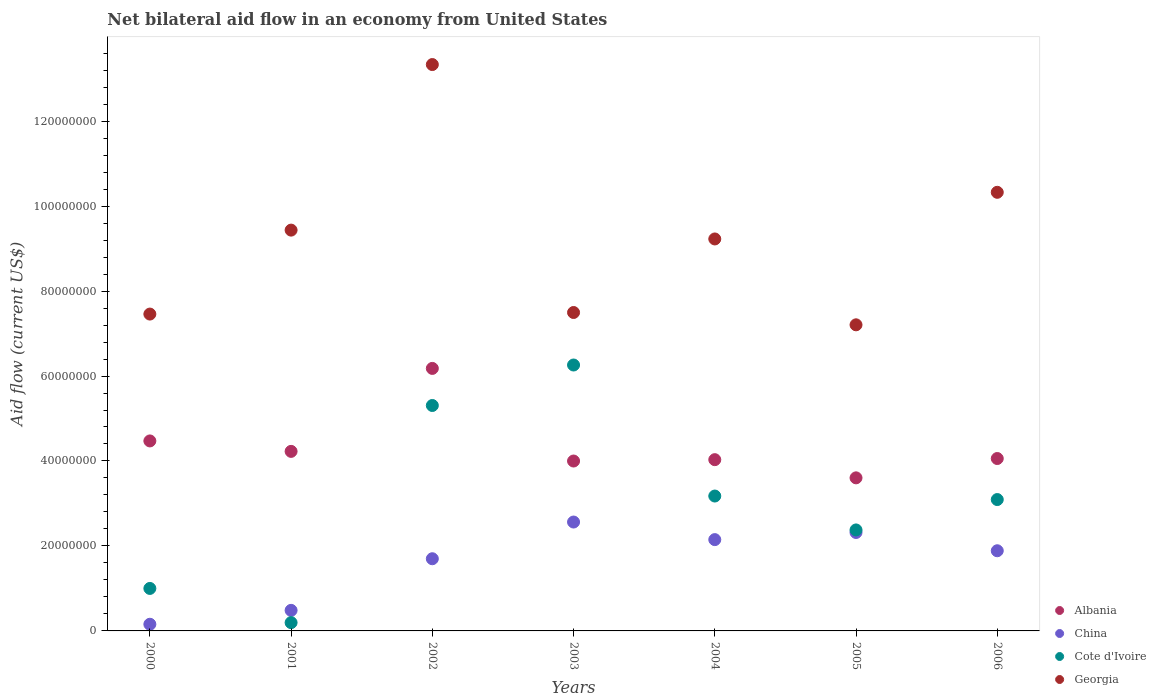How many different coloured dotlines are there?
Your answer should be very brief. 4. What is the net bilateral aid flow in China in 2002?
Provide a succinct answer. 1.70e+07. Across all years, what is the maximum net bilateral aid flow in China?
Your answer should be compact. 2.56e+07. Across all years, what is the minimum net bilateral aid flow in Cote d'Ivoire?
Offer a terse response. 1.95e+06. What is the total net bilateral aid flow in China in the graph?
Your answer should be compact. 1.13e+08. What is the difference between the net bilateral aid flow in Albania in 2002 and that in 2006?
Ensure brevity in your answer.  2.12e+07. What is the difference between the net bilateral aid flow in China in 2002 and the net bilateral aid flow in Georgia in 2000?
Your answer should be very brief. -5.76e+07. What is the average net bilateral aid flow in Albania per year?
Make the answer very short. 4.37e+07. In the year 2001, what is the difference between the net bilateral aid flow in Albania and net bilateral aid flow in Georgia?
Your response must be concise. -5.21e+07. What is the ratio of the net bilateral aid flow in China in 2004 to that in 2006?
Provide a succinct answer. 1.14. What is the difference between the highest and the second highest net bilateral aid flow in Cote d'Ivoire?
Provide a short and direct response. 9.53e+06. What is the difference between the highest and the lowest net bilateral aid flow in Cote d'Ivoire?
Your response must be concise. 6.06e+07. In how many years, is the net bilateral aid flow in China greater than the average net bilateral aid flow in China taken over all years?
Give a very brief answer. 5. Is it the case that in every year, the sum of the net bilateral aid flow in China and net bilateral aid flow in Georgia  is greater than the net bilateral aid flow in Albania?
Make the answer very short. Yes. Does the net bilateral aid flow in Albania monotonically increase over the years?
Offer a terse response. No. Is the net bilateral aid flow in Albania strictly greater than the net bilateral aid flow in Georgia over the years?
Provide a succinct answer. No. Is the net bilateral aid flow in Cote d'Ivoire strictly less than the net bilateral aid flow in Albania over the years?
Make the answer very short. No. Are the values on the major ticks of Y-axis written in scientific E-notation?
Your answer should be very brief. No. Does the graph contain any zero values?
Offer a very short reply. No. Does the graph contain grids?
Your answer should be very brief. No. How are the legend labels stacked?
Keep it short and to the point. Vertical. What is the title of the graph?
Your answer should be very brief. Net bilateral aid flow in an economy from United States. What is the label or title of the Y-axis?
Give a very brief answer. Aid flow (current US$). What is the Aid flow (current US$) of Albania in 2000?
Offer a terse response. 4.47e+07. What is the Aid flow (current US$) in China in 2000?
Your answer should be very brief. 1.57e+06. What is the Aid flow (current US$) in Georgia in 2000?
Ensure brevity in your answer.  7.46e+07. What is the Aid flow (current US$) in Albania in 2001?
Offer a very short reply. 4.23e+07. What is the Aid flow (current US$) in China in 2001?
Make the answer very short. 4.84e+06. What is the Aid flow (current US$) of Cote d'Ivoire in 2001?
Offer a very short reply. 1.95e+06. What is the Aid flow (current US$) in Georgia in 2001?
Ensure brevity in your answer.  9.43e+07. What is the Aid flow (current US$) in Albania in 2002?
Make the answer very short. 6.18e+07. What is the Aid flow (current US$) in China in 2002?
Keep it short and to the point. 1.70e+07. What is the Aid flow (current US$) of Cote d'Ivoire in 2002?
Offer a terse response. 5.31e+07. What is the Aid flow (current US$) of Georgia in 2002?
Make the answer very short. 1.33e+08. What is the Aid flow (current US$) of Albania in 2003?
Keep it short and to the point. 4.00e+07. What is the Aid flow (current US$) in China in 2003?
Give a very brief answer. 2.56e+07. What is the Aid flow (current US$) in Cote d'Ivoire in 2003?
Offer a terse response. 6.26e+07. What is the Aid flow (current US$) in Georgia in 2003?
Your answer should be compact. 7.50e+07. What is the Aid flow (current US$) in Albania in 2004?
Make the answer very short. 4.03e+07. What is the Aid flow (current US$) in China in 2004?
Provide a short and direct response. 2.15e+07. What is the Aid flow (current US$) of Cote d'Ivoire in 2004?
Your response must be concise. 3.18e+07. What is the Aid flow (current US$) of Georgia in 2004?
Keep it short and to the point. 9.23e+07. What is the Aid flow (current US$) in Albania in 2005?
Keep it short and to the point. 3.60e+07. What is the Aid flow (current US$) in China in 2005?
Give a very brief answer. 2.32e+07. What is the Aid flow (current US$) of Cote d'Ivoire in 2005?
Offer a terse response. 2.38e+07. What is the Aid flow (current US$) of Georgia in 2005?
Your answer should be compact. 7.20e+07. What is the Aid flow (current US$) of Albania in 2006?
Keep it short and to the point. 4.06e+07. What is the Aid flow (current US$) in China in 2006?
Give a very brief answer. 1.89e+07. What is the Aid flow (current US$) in Cote d'Ivoire in 2006?
Provide a succinct answer. 3.09e+07. What is the Aid flow (current US$) of Georgia in 2006?
Your response must be concise. 1.03e+08. Across all years, what is the maximum Aid flow (current US$) of Albania?
Provide a succinct answer. 6.18e+07. Across all years, what is the maximum Aid flow (current US$) in China?
Give a very brief answer. 2.56e+07. Across all years, what is the maximum Aid flow (current US$) in Cote d'Ivoire?
Your answer should be compact. 6.26e+07. Across all years, what is the maximum Aid flow (current US$) in Georgia?
Make the answer very short. 1.33e+08. Across all years, what is the minimum Aid flow (current US$) in Albania?
Keep it short and to the point. 3.60e+07. Across all years, what is the minimum Aid flow (current US$) of China?
Keep it short and to the point. 1.57e+06. Across all years, what is the minimum Aid flow (current US$) of Cote d'Ivoire?
Ensure brevity in your answer.  1.95e+06. Across all years, what is the minimum Aid flow (current US$) in Georgia?
Offer a very short reply. 7.20e+07. What is the total Aid flow (current US$) of Albania in the graph?
Give a very brief answer. 3.06e+08. What is the total Aid flow (current US$) of China in the graph?
Keep it short and to the point. 1.13e+08. What is the total Aid flow (current US$) in Cote d'Ivoire in the graph?
Make the answer very short. 2.14e+08. What is the total Aid flow (current US$) in Georgia in the graph?
Make the answer very short. 6.45e+08. What is the difference between the Aid flow (current US$) of Albania in 2000 and that in 2001?
Keep it short and to the point. 2.46e+06. What is the difference between the Aid flow (current US$) in China in 2000 and that in 2001?
Give a very brief answer. -3.27e+06. What is the difference between the Aid flow (current US$) in Cote d'Ivoire in 2000 and that in 2001?
Ensure brevity in your answer.  8.05e+06. What is the difference between the Aid flow (current US$) of Georgia in 2000 and that in 2001?
Provide a succinct answer. -1.98e+07. What is the difference between the Aid flow (current US$) of Albania in 2000 and that in 2002?
Offer a very short reply. -1.71e+07. What is the difference between the Aid flow (current US$) in China in 2000 and that in 2002?
Your answer should be compact. -1.54e+07. What is the difference between the Aid flow (current US$) of Cote d'Ivoire in 2000 and that in 2002?
Offer a terse response. -4.31e+07. What is the difference between the Aid flow (current US$) in Georgia in 2000 and that in 2002?
Offer a very short reply. -5.87e+07. What is the difference between the Aid flow (current US$) of Albania in 2000 and that in 2003?
Your answer should be very brief. 4.73e+06. What is the difference between the Aid flow (current US$) in China in 2000 and that in 2003?
Your answer should be very brief. -2.41e+07. What is the difference between the Aid flow (current US$) in Cote d'Ivoire in 2000 and that in 2003?
Your response must be concise. -5.26e+07. What is the difference between the Aid flow (current US$) in Georgia in 2000 and that in 2003?
Offer a very short reply. -3.70e+05. What is the difference between the Aid flow (current US$) of Albania in 2000 and that in 2004?
Your answer should be compact. 4.41e+06. What is the difference between the Aid flow (current US$) of China in 2000 and that in 2004?
Ensure brevity in your answer.  -1.99e+07. What is the difference between the Aid flow (current US$) in Cote d'Ivoire in 2000 and that in 2004?
Provide a succinct answer. -2.18e+07. What is the difference between the Aid flow (current US$) of Georgia in 2000 and that in 2004?
Ensure brevity in your answer.  -1.77e+07. What is the difference between the Aid flow (current US$) of Albania in 2000 and that in 2005?
Keep it short and to the point. 8.69e+06. What is the difference between the Aid flow (current US$) of China in 2000 and that in 2005?
Give a very brief answer. -2.16e+07. What is the difference between the Aid flow (current US$) in Cote d'Ivoire in 2000 and that in 2005?
Your answer should be compact. -1.38e+07. What is the difference between the Aid flow (current US$) of Georgia in 2000 and that in 2005?
Keep it short and to the point. 2.53e+06. What is the difference between the Aid flow (current US$) of Albania in 2000 and that in 2006?
Your answer should be very brief. 4.14e+06. What is the difference between the Aid flow (current US$) in China in 2000 and that in 2006?
Offer a very short reply. -1.73e+07. What is the difference between the Aid flow (current US$) in Cote d'Ivoire in 2000 and that in 2006?
Your response must be concise. -2.09e+07. What is the difference between the Aid flow (current US$) of Georgia in 2000 and that in 2006?
Provide a succinct answer. -2.87e+07. What is the difference between the Aid flow (current US$) of Albania in 2001 and that in 2002?
Provide a short and direct response. -1.95e+07. What is the difference between the Aid flow (current US$) in China in 2001 and that in 2002?
Offer a very short reply. -1.22e+07. What is the difference between the Aid flow (current US$) of Cote d'Ivoire in 2001 and that in 2002?
Offer a very short reply. -5.11e+07. What is the difference between the Aid flow (current US$) of Georgia in 2001 and that in 2002?
Offer a very short reply. -3.90e+07. What is the difference between the Aid flow (current US$) of Albania in 2001 and that in 2003?
Your answer should be compact. 2.27e+06. What is the difference between the Aid flow (current US$) in China in 2001 and that in 2003?
Offer a terse response. -2.08e+07. What is the difference between the Aid flow (current US$) in Cote d'Ivoire in 2001 and that in 2003?
Offer a terse response. -6.06e+07. What is the difference between the Aid flow (current US$) of Georgia in 2001 and that in 2003?
Your answer should be compact. 1.94e+07. What is the difference between the Aid flow (current US$) in Albania in 2001 and that in 2004?
Ensure brevity in your answer.  1.95e+06. What is the difference between the Aid flow (current US$) in China in 2001 and that in 2004?
Provide a succinct answer. -1.66e+07. What is the difference between the Aid flow (current US$) in Cote d'Ivoire in 2001 and that in 2004?
Give a very brief answer. -2.98e+07. What is the difference between the Aid flow (current US$) of Georgia in 2001 and that in 2004?
Keep it short and to the point. 2.08e+06. What is the difference between the Aid flow (current US$) in Albania in 2001 and that in 2005?
Your answer should be very brief. 6.23e+06. What is the difference between the Aid flow (current US$) in China in 2001 and that in 2005?
Make the answer very short. -1.83e+07. What is the difference between the Aid flow (current US$) of Cote d'Ivoire in 2001 and that in 2005?
Make the answer very short. -2.18e+07. What is the difference between the Aid flow (current US$) of Georgia in 2001 and that in 2005?
Ensure brevity in your answer.  2.23e+07. What is the difference between the Aid flow (current US$) of Albania in 2001 and that in 2006?
Offer a terse response. 1.68e+06. What is the difference between the Aid flow (current US$) in China in 2001 and that in 2006?
Your answer should be very brief. -1.40e+07. What is the difference between the Aid flow (current US$) in Cote d'Ivoire in 2001 and that in 2006?
Offer a terse response. -2.90e+07. What is the difference between the Aid flow (current US$) in Georgia in 2001 and that in 2006?
Your response must be concise. -8.90e+06. What is the difference between the Aid flow (current US$) of Albania in 2002 and that in 2003?
Provide a succinct answer. 2.18e+07. What is the difference between the Aid flow (current US$) of China in 2002 and that in 2003?
Offer a very short reply. -8.64e+06. What is the difference between the Aid flow (current US$) of Cote d'Ivoire in 2002 and that in 2003?
Keep it short and to the point. -9.53e+06. What is the difference between the Aid flow (current US$) in Georgia in 2002 and that in 2003?
Offer a terse response. 5.84e+07. What is the difference between the Aid flow (current US$) of Albania in 2002 and that in 2004?
Your answer should be very brief. 2.15e+07. What is the difference between the Aid flow (current US$) in China in 2002 and that in 2004?
Make the answer very short. -4.50e+06. What is the difference between the Aid flow (current US$) of Cote d'Ivoire in 2002 and that in 2004?
Make the answer very short. 2.13e+07. What is the difference between the Aid flow (current US$) in Georgia in 2002 and that in 2004?
Ensure brevity in your answer.  4.10e+07. What is the difference between the Aid flow (current US$) of Albania in 2002 and that in 2005?
Keep it short and to the point. 2.58e+07. What is the difference between the Aid flow (current US$) in China in 2002 and that in 2005?
Keep it short and to the point. -6.18e+06. What is the difference between the Aid flow (current US$) of Cote d'Ivoire in 2002 and that in 2005?
Your answer should be very brief. 2.93e+07. What is the difference between the Aid flow (current US$) in Georgia in 2002 and that in 2005?
Provide a succinct answer. 6.13e+07. What is the difference between the Aid flow (current US$) in Albania in 2002 and that in 2006?
Make the answer very short. 2.12e+07. What is the difference between the Aid flow (current US$) in China in 2002 and that in 2006?
Provide a short and direct response. -1.88e+06. What is the difference between the Aid flow (current US$) of Cote d'Ivoire in 2002 and that in 2006?
Ensure brevity in your answer.  2.21e+07. What is the difference between the Aid flow (current US$) in Georgia in 2002 and that in 2006?
Provide a short and direct response. 3.01e+07. What is the difference between the Aid flow (current US$) in Albania in 2003 and that in 2004?
Ensure brevity in your answer.  -3.20e+05. What is the difference between the Aid flow (current US$) in China in 2003 and that in 2004?
Keep it short and to the point. 4.14e+06. What is the difference between the Aid flow (current US$) in Cote d'Ivoire in 2003 and that in 2004?
Offer a very short reply. 3.08e+07. What is the difference between the Aid flow (current US$) in Georgia in 2003 and that in 2004?
Your answer should be very brief. -1.73e+07. What is the difference between the Aid flow (current US$) of Albania in 2003 and that in 2005?
Provide a succinct answer. 3.96e+06. What is the difference between the Aid flow (current US$) of China in 2003 and that in 2005?
Offer a very short reply. 2.46e+06. What is the difference between the Aid flow (current US$) in Cote d'Ivoire in 2003 and that in 2005?
Your answer should be compact. 3.88e+07. What is the difference between the Aid flow (current US$) of Georgia in 2003 and that in 2005?
Provide a short and direct response. 2.90e+06. What is the difference between the Aid flow (current US$) of Albania in 2003 and that in 2006?
Your answer should be compact. -5.90e+05. What is the difference between the Aid flow (current US$) in China in 2003 and that in 2006?
Give a very brief answer. 6.76e+06. What is the difference between the Aid flow (current US$) of Cote d'Ivoire in 2003 and that in 2006?
Offer a terse response. 3.17e+07. What is the difference between the Aid flow (current US$) in Georgia in 2003 and that in 2006?
Your response must be concise. -2.83e+07. What is the difference between the Aid flow (current US$) of Albania in 2004 and that in 2005?
Keep it short and to the point. 4.28e+06. What is the difference between the Aid flow (current US$) in China in 2004 and that in 2005?
Ensure brevity in your answer.  -1.68e+06. What is the difference between the Aid flow (current US$) in Cote d'Ivoire in 2004 and that in 2005?
Keep it short and to the point. 7.98e+06. What is the difference between the Aid flow (current US$) in Georgia in 2004 and that in 2005?
Your answer should be compact. 2.02e+07. What is the difference between the Aid flow (current US$) in China in 2004 and that in 2006?
Your answer should be very brief. 2.62e+06. What is the difference between the Aid flow (current US$) in Cote d'Ivoire in 2004 and that in 2006?
Offer a very short reply. 8.30e+05. What is the difference between the Aid flow (current US$) of Georgia in 2004 and that in 2006?
Your answer should be compact. -1.10e+07. What is the difference between the Aid flow (current US$) of Albania in 2005 and that in 2006?
Your answer should be very brief. -4.55e+06. What is the difference between the Aid flow (current US$) of China in 2005 and that in 2006?
Ensure brevity in your answer.  4.30e+06. What is the difference between the Aid flow (current US$) of Cote d'Ivoire in 2005 and that in 2006?
Your answer should be very brief. -7.15e+06. What is the difference between the Aid flow (current US$) in Georgia in 2005 and that in 2006?
Your response must be concise. -3.12e+07. What is the difference between the Aid flow (current US$) in Albania in 2000 and the Aid flow (current US$) in China in 2001?
Give a very brief answer. 3.99e+07. What is the difference between the Aid flow (current US$) in Albania in 2000 and the Aid flow (current US$) in Cote d'Ivoire in 2001?
Provide a short and direct response. 4.28e+07. What is the difference between the Aid flow (current US$) in Albania in 2000 and the Aid flow (current US$) in Georgia in 2001?
Offer a very short reply. -4.96e+07. What is the difference between the Aid flow (current US$) in China in 2000 and the Aid flow (current US$) in Cote d'Ivoire in 2001?
Provide a succinct answer. -3.80e+05. What is the difference between the Aid flow (current US$) of China in 2000 and the Aid flow (current US$) of Georgia in 2001?
Your response must be concise. -9.28e+07. What is the difference between the Aid flow (current US$) of Cote d'Ivoire in 2000 and the Aid flow (current US$) of Georgia in 2001?
Your answer should be very brief. -8.43e+07. What is the difference between the Aid flow (current US$) of Albania in 2000 and the Aid flow (current US$) of China in 2002?
Offer a terse response. 2.77e+07. What is the difference between the Aid flow (current US$) in Albania in 2000 and the Aid flow (current US$) in Cote d'Ivoire in 2002?
Offer a terse response. -8.34e+06. What is the difference between the Aid flow (current US$) in Albania in 2000 and the Aid flow (current US$) in Georgia in 2002?
Your answer should be compact. -8.86e+07. What is the difference between the Aid flow (current US$) of China in 2000 and the Aid flow (current US$) of Cote d'Ivoire in 2002?
Ensure brevity in your answer.  -5.15e+07. What is the difference between the Aid flow (current US$) of China in 2000 and the Aid flow (current US$) of Georgia in 2002?
Your answer should be very brief. -1.32e+08. What is the difference between the Aid flow (current US$) in Cote d'Ivoire in 2000 and the Aid flow (current US$) in Georgia in 2002?
Ensure brevity in your answer.  -1.23e+08. What is the difference between the Aid flow (current US$) in Albania in 2000 and the Aid flow (current US$) in China in 2003?
Offer a terse response. 1.91e+07. What is the difference between the Aid flow (current US$) of Albania in 2000 and the Aid flow (current US$) of Cote d'Ivoire in 2003?
Keep it short and to the point. -1.79e+07. What is the difference between the Aid flow (current US$) in Albania in 2000 and the Aid flow (current US$) in Georgia in 2003?
Ensure brevity in your answer.  -3.02e+07. What is the difference between the Aid flow (current US$) in China in 2000 and the Aid flow (current US$) in Cote d'Ivoire in 2003?
Give a very brief answer. -6.10e+07. What is the difference between the Aid flow (current US$) of China in 2000 and the Aid flow (current US$) of Georgia in 2003?
Your answer should be compact. -7.34e+07. What is the difference between the Aid flow (current US$) of Cote d'Ivoire in 2000 and the Aid flow (current US$) of Georgia in 2003?
Keep it short and to the point. -6.50e+07. What is the difference between the Aid flow (current US$) of Albania in 2000 and the Aid flow (current US$) of China in 2004?
Offer a terse response. 2.32e+07. What is the difference between the Aid flow (current US$) of Albania in 2000 and the Aid flow (current US$) of Cote d'Ivoire in 2004?
Offer a terse response. 1.30e+07. What is the difference between the Aid flow (current US$) of Albania in 2000 and the Aid flow (current US$) of Georgia in 2004?
Keep it short and to the point. -4.75e+07. What is the difference between the Aid flow (current US$) in China in 2000 and the Aid flow (current US$) in Cote d'Ivoire in 2004?
Your response must be concise. -3.02e+07. What is the difference between the Aid flow (current US$) of China in 2000 and the Aid flow (current US$) of Georgia in 2004?
Ensure brevity in your answer.  -9.07e+07. What is the difference between the Aid flow (current US$) of Cote d'Ivoire in 2000 and the Aid flow (current US$) of Georgia in 2004?
Make the answer very short. -8.23e+07. What is the difference between the Aid flow (current US$) in Albania in 2000 and the Aid flow (current US$) in China in 2005?
Make the answer very short. 2.16e+07. What is the difference between the Aid flow (current US$) in Albania in 2000 and the Aid flow (current US$) in Cote d'Ivoire in 2005?
Provide a succinct answer. 2.10e+07. What is the difference between the Aid flow (current US$) of Albania in 2000 and the Aid flow (current US$) of Georgia in 2005?
Provide a short and direct response. -2.73e+07. What is the difference between the Aid flow (current US$) in China in 2000 and the Aid flow (current US$) in Cote d'Ivoire in 2005?
Ensure brevity in your answer.  -2.22e+07. What is the difference between the Aid flow (current US$) in China in 2000 and the Aid flow (current US$) in Georgia in 2005?
Your answer should be very brief. -7.05e+07. What is the difference between the Aid flow (current US$) of Cote d'Ivoire in 2000 and the Aid flow (current US$) of Georgia in 2005?
Keep it short and to the point. -6.20e+07. What is the difference between the Aid flow (current US$) in Albania in 2000 and the Aid flow (current US$) in China in 2006?
Provide a short and direct response. 2.58e+07. What is the difference between the Aid flow (current US$) in Albania in 2000 and the Aid flow (current US$) in Cote d'Ivoire in 2006?
Give a very brief answer. 1.38e+07. What is the difference between the Aid flow (current US$) in Albania in 2000 and the Aid flow (current US$) in Georgia in 2006?
Keep it short and to the point. -5.85e+07. What is the difference between the Aid flow (current US$) in China in 2000 and the Aid flow (current US$) in Cote d'Ivoire in 2006?
Make the answer very short. -2.94e+07. What is the difference between the Aid flow (current US$) in China in 2000 and the Aid flow (current US$) in Georgia in 2006?
Offer a very short reply. -1.02e+08. What is the difference between the Aid flow (current US$) in Cote d'Ivoire in 2000 and the Aid flow (current US$) in Georgia in 2006?
Keep it short and to the point. -9.32e+07. What is the difference between the Aid flow (current US$) of Albania in 2001 and the Aid flow (current US$) of China in 2002?
Give a very brief answer. 2.53e+07. What is the difference between the Aid flow (current US$) of Albania in 2001 and the Aid flow (current US$) of Cote d'Ivoire in 2002?
Provide a short and direct response. -1.08e+07. What is the difference between the Aid flow (current US$) in Albania in 2001 and the Aid flow (current US$) in Georgia in 2002?
Provide a short and direct response. -9.10e+07. What is the difference between the Aid flow (current US$) in China in 2001 and the Aid flow (current US$) in Cote d'Ivoire in 2002?
Offer a terse response. -4.82e+07. What is the difference between the Aid flow (current US$) in China in 2001 and the Aid flow (current US$) in Georgia in 2002?
Offer a terse response. -1.28e+08. What is the difference between the Aid flow (current US$) of Cote d'Ivoire in 2001 and the Aid flow (current US$) of Georgia in 2002?
Provide a succinct answer. -1.31e+08. What is the difference between the Aid flow (current US$) of Albania in 2001 and the Aid flow (current US$) of China in 2003?
Keep it short and to the point. 1.66e+07. What is the difference between the Aid flow (current US$) in Albania in 2001 and the Aid flow (current US$) in Cote d'Ivoire in 2003?
Your answer should be compact. -2.03e+07. What is the difference between the Aid flow (current US$) in Albania in 2001 and the Aid flow (current US$) in Georgia in 2003?
Offer a terse response. -3.27e+07. What is the difference between the Aid flow (current US$) of China in 2001 and the Aid flow (current US$) of Cote d'Ivoire in 2003?
Your answer should be very brief. -5.78e+07. What is the difference between the Aid flow (current US$) in China in 2001 and the Aid flow (current US$) in Georgia in 2003?
Your answer should be very brief. -7.01e+07. What is the difference between the Aid flow (current US$) of Cote d'Ivoire in 2001 and the Aid flow (current US$) of Georgia in 2003?
Provide a succinct answer. -7.30e+07. What is the difference between the Aid flow (current US$) in Albania in 2001 and the Aid flow (current US$) in China in 2004?
Offer a very short reply. 2.08e+07. What is the difference between the Aid flow (current US$) of Albania in 2001 and the Aid flow (current US$) of Cote d'Ivoire in 2004?
Provide a succinct answer. 1.05e+07. What is the difference between the Aid flow (current US$) of Albania in 2001 and the Aid flow (current US$) of Georgia in 2004?
Ensure brevity in your answer.  -5.00e+07. What is the difference between the Aid flow (current US$) in China in 2001 and the Aid flow (current US$) in Cote d'Ivoire in 2004?
Offer a terse response. -2.69e+07. What is the difference between the Aid flow (current US$) in China in 2001 and the Aid flow (current US$) in Georgia in 2004?
Ensure brevity in your answer.  -8.74e+07. What is the difference between the Aid flow (current US$) of Cote d'Ivoire in 2001 and the Aid flow (current US$) of Georgia in 2004?
Give a very brief answer. -9.03e+07. What is the difference between the Aid flow (current US$) of Albania in 2001 and the Aid flow (current US$) of China in 2005?
Your answer should be compact. 1.91e+07. What is the difference between the Aid flow (current US$) in Albania in 2001 and the Aid flow (current US$) in Cote d'Ivoire in 2005?
Offer a very short reply. 1.85e+07. What is the difference between the Aid flow (current US$) of Albania in 2001 and the Aid flow (current US$) of Georgia in 2005?
Your answer should be compact. -2.98e+07. What is the difference between the Aid flow (current US$) in China in 2001 and the Aid flow (current US$) in Cote d'Ivoire in 2005?
Offer a terse response. -1.89e+07. What is the difference between the Aid flow (current US$) of China in 2001 and the Aid flow (current US$) of Georgia in 2005?
Your answer should be very brief. -6.72e+07. What is the difference between the Aid flow (current US$) in Cote d'Ivoire in 2001 and the Aid flow (current US$) in Georgia in 2005?
Offer a very short reply. -7.01e+07. What is the difference between the Aid flow (current US$) of Albania in 2001 and the Aid flow (current US$) of China in 2006?
Offer a terse response. 2.34e+07. What is the difference between the Aid flow (current US$) in Albania in 2001 and the Aid flow (current US$) in Cote d'Ivoire in 2006?
Offer a terse response. 1.13e+07. What is the difference between the Aid flow (current US$) of Albania in 2001 and the Aid flow (current US$) of Georgia in 2006?
Keep it short and to the point. -6.10e+07. What is the difference between the Aid flow (current US$) in China in 2001 and the Aid flow (current US$) in Cote d'Ivoire in 2006?
Offer a very short reply. -2.61e+07. What is the difference between the Aid flow (current US$) of China in 2001 and the Aid flow (current US$) of Georgia in 2006?
Provide a short and direct response. -9.84e+07. What is the difference between the Aid flow (current US$) in Cote d'Ivoire in 2001 and the Aid flow (current US$) in Georgia in 2006?
Offer a very short reply. -1.01e+08. What is the difference between the Aid flow (current US$) of Albania in 2002 and the Aid flow (current US$) of China in 2003?
Ensure brevity in your answer.  3.62e+07. What is the difference between the Aid flow (current US$) of Albania in 2002 and the Aid flow (current US$) of Cote d'Ivoire in 2003?
Your answer should be very brief. -8.00e+05. What is the difference between the Aid flow (current US$) of Albania in 2002 and the Aid flow (current US$) of Georgia in 2003?
Offer a very short reply. -1.32e+07. What is the difference between the Aid flow (current US$) in China in 2002 and the Aid flow (current US$) in Cote d'Ivoire in 2003?
Your response must be concise. -4.56e+07. What is the difference between the Aid flow (current US$) in China in 2002 and the Aid flow (current US$) in Georgia in 2003?
Provide a short and direct response. -5.80e+07. What is the difference between the Aid flow (current US$) of Cote d'Ivoire in 2002 and the Aid flow (current US$) of Georgia in 2003?
Offer a very short reply. -2.19e+07. What is the difference between the Aid flow (current US$) of Albania in 2002 and the Aid flow (current US$) of China in 2004?
Offer a terse response. 4.03e+07. What is the difference between the Aid flow (current US$) in Albania in 2002 and the Aid flow (current US$) in Cote d'Ivoire in 2004?
Offer a very short reply. 3.00e+07. What is the difference between the Aid flow (current US$) of Albania in 2002 and the Aid flow (current US$) of Georgia in 2004?
Your answer should be compact. -3.05e+07. What is the difference between the Aid flow (current US$) of China in 2002 and the Aid flow (current US$) of Cote d'Ivoire in 2004?
Offer a terse response. -1.48e+07. What is the difference between the Aid flow (current US$) of China in 2002 and the Aid flow (current US$) of Georgia in 2004?
Provide a short and direct response. -7.53e+07. What is the difference between the Aid flow (current US$) in Cote d'Ivoire in 2002 and the Aid flow (current US$) in Georgia in 2004?
Your answer should be very brief. -3.92e+07. What is the difference between the Aid flow (current US$) of Albania in 2002 and the Aid flow (current US$) of China in 2005?
Your response must be concise. 3.86e+07. What is the difference between the Aid flow (current US$) of Albania in 2002 and the Aid flow (current US$) of Cote d'Ivoire in 2005?
Provide a succinct answer. 3.80e+07. What is the difference between the Aid flow (current US$) in Albania in 2002 and the Aid flow (current US$) in Georgia in 2005?
Your response must be concise. -1.03e+07. What is the difference between the Aid flow (current US$) of China in 2002 and the Aid flow (current US$) of Cote d'Ivoire in 2005?
Ensure brevity in your answer.  -6.78e+06. What is the difference between the Aid flow (current US$) in China in 2002 and the Aid flow (current US$) in Georgia in 2005?
Ensure brevity in your answer.  -5.51e+07. What is the difference between the Aid flow (current US$) of Cote d'Ivoire in 2002 and the Aid flow (current US$) of Georgia in 2005?
Offer a terse response. -1.90e+07. What is the difference between the Aid flow (current US$) of Albania in 2002 and the Aid flow (current US$) of China in 2006?
Offer a terse response. 4.29e+07. What is the difference between the Aid flow (current US$) of Albania in 2002 and the Aid flow (current US$) of Cote d'Ivoire in 2006?
Your answer should be compact. 3.09e+07. What is the difference between the Aid flow (current US$) in Albania in 2002 and the Aid flow (current US$) in Georgia in 2006?
Provide a short and direct response. -4.14e+07. What is the difference between the Aid flow (current US$) of China in 2002 and the Aid flow (current US$) of Cote d'Ivoire in 2006?
Make the answer very short. -1.39e+07. What is the difference between the Aid flow (current US$) of China in 2002 and the Aid flow (current US$) of Georgia in 2006?
Provide a succinct answer. -8.62e+07. What is the difference between the Aid flow (current US$) in Cote d'Ivoire in 2002 and the Aid flow (current US$) in Georgia in 2006?
Offer a very short reply. -5.02e+07. What is the difference between the Aid flow (current US$) in Albania in 2003 and the Aid flow (current US$) in China in 2004?
Your answer should be compact. 1.85e+07. What is the difference between the Aid flow (current US$) of Albania in 2003 and the Aid flow (current US$) of Cote d'Ivoire in 2004?
Your answer should be very brief. 8.24e+06. What is the difference between the Aid flow (current US$) in Albania in 2003 and the Aid flow (current US$) in Georgia in 2004?
Offer a terse response. -5.23e+07. What is the difference between the Aid flow (current US$) in China in 2003 and the Aid flow (current US$) in Cote d'Ivoire in 2004?
Offer a very short reply. -6.12e+06. What is the difference between the Aid flow (current US$) of China in 2003 and the Aid flow (current US$) of Georgia in 2004?
Give a very brief answer. -6.66e+07. What is the difference between the Aid flow (current US$) in Cote d'Ivoire in 2003 and the Aid flow (current US$) in Georgia in 2004?
Ensure brevity in your answer.  -2.97e+07. What is the difference between the Aid flow (current US$) in Albania in 2003 and the Aid flow (current US$) in China in 2005?
Provide a succinct answer. 1.68e+07. What is the difference between the Aid flow (current US$) of Albania in 2003 and the Aid flow (current US$) of Cote d'Ivoire in 2005?
Your answer should be compact. 1.62e+07. What is the difference between the Aid flow (current US$) of Albania in 2003 and the Aid flow (current US$) of Georgia in 2005?
Ensure brevity in your answer.  -3.21e+07. What is the difference between the Aid flow (current US$) of China in 2003 and the Aid flow (current US$) of Cote d'Ivoire in 2005?
Your answer should be very brief. 1.86e+06. What is the difference between the Aid flow (current US$) of China in 2003 and the Aid flow (current US$) of Georgia in 2005?
Offer a very short reply. -4.64e+07. What is the difference between the Aid flow (current US$) of Cote d'Ivoire in 2003 and the Aid flow (current US$) of Georgia in 2005?
Provide a succinct answer. -9.46e+06. What is the difference between the Aid flow (current US$) of Albania in 2003 and the Aid flow (current US$) of China in 2006?
Offer a very short reply. 2.11e+07. What is the difference between the Aid flow (current US$) of Albania in 2003 and the Aid flow (current US$) of Cote d'Ivoire in 2006?
Offer a terse response. 9.07e+06. What is the difference between the Aid flow (current US$) in Albania in 2003 and the Aid flow (current US$) in Georgia in 2006?
Your answer should be compact. -6.32e+07. What is the difference between the Aid flow (current US$) of China in 2003 and the Aid flow (current US$) of Cote d'Ivoire in 2006?
Keep it short and to the point. -5.29e+06. What is the difference between the Aid flow (current US$) of China in 2003 and the Aid flow (current US$) of Georgia in 2006?
Your response must be concise. -7.76e+07. What is the difference between the Aid flow (current US$) of Cote d'Ivoire in 2003 and the Aid flow (current US$) of Georgia in 2006?
Offer a very short reply. -4.06e+07. What is the difference between the Aid flow (current US$) in Albania in 2004 and the Aid flow (current US$) in China in 2005?
Your answer should be compact. 1.71e+07. What is the difference between the Aid flow (current US$) of Albania in 2004 and the Aid flow (current US$) of Cote d'Ivoire in 2005?
Provide a succinct answer. 1.65e+07. What is the difference between the Aid flow (current US$) of Albania in 2004 and the Aid flow (current US$) of Georgia in 2005?
Your answer should be compact. -3.17e+07. What is the difference between the Aid flow (current US$) in China in 2004 and the Aid flow (current US$) in Cote d'Ivoire in 2005?
Make the answer very short. -2.28e+06. What is the difference between the Aid flow (current US$) of China in 2004 and the Aid flow (current US$) of Georgia in 2005?
Give a very brief answer. -5.06e+07. What is the difference between the Aid flow (current US$) of Cote d'Ivoire in 2004 and the Aid flow (current US$) of Georgia in 2005?
Offer a very short reply. -4.03e+07. What is the difference between the Aid flow (current US$) in Albania in 2004 and the Aid flow (current US$) in China in 2006?
Keep it short and to the point. 2.14e+07. What is the difference between the Aid flow (current US$) in Albania in 2004 and the Aid flow (current US$) in Cote d'Ivoire in 2006?
Provide a succinct answer. 9.39e+06. What is the difference between the Aid flow (current US$) of Albania in 2004 and the Aid flow (current US$) of Georgia in 2006?
Make the answer very short. -6.29e+07. What is the difference between the Aid flow (current US$) of China in 2004 and the Aid flow (current US$) of Cote d'Ivoire in 2006?
Provide a short and direct response. -9.43e+06. What is the difference between the Aid flow (current US$) in China in 2004 and the Aid flow (current US$) in Georgia in 2006?
Keep it short and to the point. -8.18e+07. What is the difference between the Aid flow (current US$) of Cote d'Ivoire in 2004 and the Aid flow (current US$) of Georgia in 2006?
Offer a very short reply. -7.15e+07. What is the difference between the Aid flow (current US$) in Albania in 2005 and the Aid flow (current US$) in China in 2006?
Offer a terse response. 1.72e+07. What is the difference between the Aid flow (current US$) of Albania in 2005 and the Aid flow (current US$) of Cote d'Ivoire in 2006?
Ensure brevity in your answer.  5.11e+06. What is the difference between the Aid flow (current US$) in Albania in 2005 and the Aid flow (current US$) in Georgia in 2006?
Provide a short and direct response. -6.72e+07. What is the difference between the Aid flow (current US$) in China in 2005 and the Aid flow (current US$) in Cote d'Ivoire in 2006?
Your response must be concise. -7.75e+06. What is the difference between the Aid flow (current US$) in China in 2005 and the Aid flow (current US$) in Georgia in 2006?
Ensure brevity in your answer.  -8.01e+07. What is the difference between the Aid flow (current US$) of Cote d'Ivoire in 2005 and the Aid flow (current US$) of Georgia in 2006?
Offer a very short reply. -7.95e+07. What is the average Aid flow (current US$) in Albania per year?
Keep it short and to the point. 4.37e+07. What is the average Aid flow (current US$) of China per year?
Offer a very short reply. 1.61e+07. What is the average Aid flow (current US$) of Cote d'Ivoire per year?
Keep it short and to the point. 3.06e+07. What is the average Aid flow (current US$) in Georgia per year?
Your answer should be compact. 9.21e+07. In the year 2000, what is the difference between the Aid flow (current US$) in Albania and Aid flow (current US$) in China?
Your response must be concise. 4.32e+07. In the year 2000, what is the difference between the Aid flow (current US$) in Albania and Aid flow (current US$) in Cote d'Ivoire?
Make the answer very short. 3.47e+07. In the year 2000, what is the difference between the Aid flow (current US$) of Albania and Aid flow (current US$) of Georgia?
Provide a short and direct response. -2.99e+07. In the year 2000, what is the difference between the Aid flow (current US$) of China and Aid flow (current US$) of Cote d'Ivoire?
Provide a succinct answer. -8.43e+06. In the year 2000, what is the difference between the Aid flow (current US$) of China and Aid flow (current US$) of Georgia?
Keep it short and to the point. -7.30e+07. In the year 2000, what is the difference between the Aid flow (current US$) in Cote d'Ivoire and Aid flow (current US$) in Georgia?
Your response must be concise. -6.46e+07. In the year 2001, what is the difference between the Aid flow (current US$) of Albania and Aid flow (current US$) of China?
Provide a short and direct response. 3.74e+07. In the year 2001, what is the difference between the Aid flow (current US$) in Albania and Aid flow (current US$) in Cote d'Ivoire?
Keep it short and to the point. 4.03e+07. In the year 2001, what is the difference between the Aid flow (current US$) in Albania and Aid flow (current US$) in Georgia?
Provide a succinct answer. -5.21e+07. In the year 2001, what is the difference between the Aid flow (current US$) in China and Aid flow (current US$) in Cote d'Ivoire?
Offer a very short reply. 2.89e+06. In the year 2001, what is the difference between the Aid flow (current US$) of China and Aid flow (current US$) of Georgia?
Make the answer very short. -8.95e+07. In the year 2001, what is the difference between the Aid flow (current US$) in Cote d'Ivoire and Aid flow (current US$) in Georgia?
Offer a very short reply. -9.24e+07. In the year 2002, what is the difference between the Aid flow (current US$) of Albania and Aid flow (current US$) of China?
Offer a terse response. 4.48e+07. In the year 2002, what is the difference between the Aid flow (current US$) in Albania and Aid flow (current US$) in Cote d'Ivoire?
Offer a very short reply. 8.73e+06. In the year 2002, what is the difference between the Aid flow (current US$) of Albania and Aid flow (current US$) of Georgia?
Keep it short and to the point. -7.15e+07. In the year 2002, what is the difference between the Aid flow (current US$) of China and Aid flow (current US$) of Cote d'Ivoire?
Keep it short and to the point. -3.61e+07. In the year 2002, what is the difference between the Aid flow (current US$) in China and Aid flow (current US$) in Georgia?
Provide a succinct answer. -1.16e+08. In the year 2002, what is the difference between the Aid flow (current US$) of Cote d'Ivoire and Aid flow (current US$) of Georgia?
Ensure brevity in your answer.  -8.02e+07. In the year 2003, what is the difference between the Aid flow (current US$) of Albania and Aid flow (current US$) of China?
Your answer should be very brief. 1.44e+07. In the year 2003, what is the difference between the Aid flow (current US$) in Albania and Aid flow (current US$) in Cote d'Ivoire?
Provide a succinct answer. -2.26e+07. In the year 2003, what is the difference between the Aid flow (current US$) of Albania and Aid flow (current US$) of Georgia?
Provide a short and direct response. -3.50e+07. In the year 2003, what is the difference between the Aid flow (current US$) of China and Aid flow (current US$) of Cote d'Ivoire?
Give a very brief answer. -3.70e+07. In the year 2003, what is the difference between the Aid flow (current US$) of China and Aid flow (current US$) of Georgia?
Make the answer very short. -4.93e+07. In the year 2003, what is the difference between the Aid flow (current US$) of Cote d'Ivoire and Aid flow (current US$) of Georgia?
Make the answer very short. -1.24e+07. In the year 2004, what is the difference between the Aid flow (current US$) in Albania and Aid flow (current US$) in China?
Make the answer very short. 1.88e+07. In the year 2004, what is the difference between the Aid flow (current US$) in Albania and Aid flow (current US$) in Cote d'Ivoire?
Your answer should be compact. 8.56e+06. In the year 2004, what is the difference between the Aid flow (current US$) of Albania and Aid flow (current US$) of Georgia?
Make the answer very short. -5.20e+07. In the year 2004, what is the difference between the Aid flow (current US$) of China and Aid flow (current US$) of Cote d'Ivoire?
Offer a very short reply. -1.03e+07. In the year 2004, what is the difference between the Aid flow (current US$) of China and Aid flow (current US$) of Georgia?
Your response must be concise. -7.08e+07. In the year 2004, what is the difference between the Aid flow (current US$) in Cote d'Ivoire and Aid flow (current US$) in Georgia?
Your response must be concise. -6.05e+07. In the year 2005, what is the difference between the Aid flow (current US$) in Albania and Aid flow (current US$) in China?
Give a very brief answer. 1.29e+07. In the year 2005, what is the difference between the Aid flow (current US$) of Albania and Aid flow (current US$) of Cote d'Ivoire?
Your response must be concise. 1.23e+07. In the year 2005, what is the difference between the Aid flow (current US$) in Albania and Aid flow (current US$) in Georgia?
Ensure brevity in your answer.  -3.60e+07. In the year 2005, what is the difference between the Aid flow (current US$) in China and Aid flow (current US$) in Cote d'Ivoire?
Keep it short and to the point. -6.00e+05. In the year 2005, what is the difference between the Aid flow (current US$) of China and Aid flow (current US$) of Georgia?
Your answer should be compact. -4.89e+07. In the year 2005, what is the difference between the Aid flow (current US$) of Cote d'Ivoire and Aid flow (current US$) of Georgia?
Keep it short and to the point. -4.83e+07. In the year 2006, what is the difference between the Aid flow (current US$) of Albania and Aid flow (current US$) of China?
Make the answer very short. 2.17e+07. In the year 2006, what is the difference between the Aid flow (current US$) of Albania and Aid flow (current US$) of Cote d'Ivoire?
Your answer should be very brief. 9.66e+06. In the year 2006, what is the difference between the Aid flow (current US$) of Albania and Aid flow (current US$) of Georgia?
Ensure brevity in your answer.  -6.27e+07. In the year 2006, what is the difference between the Aid flow (current US$) in China and Aid flow (current US$) in Cote d'Ivoire?
Your answer should be very brief. -1.20e+07. In the year 2006, what is the difference between the Aid flow (current US$) of China and Aid flow (current US$) of Georgia?
Offer a very short reply. -8.44e+07. In the year 2006, what is the difference between the Aid flow (current US$) in Cote d'Ivoire and Aid flow (current US$) in Georgia?
Your answer should be very brief. -7.23e+07. What is the ratio of the Aid flow (current US$) of Albania in 2000 to that in 2001?
Your answer should be compact. 1.06. What is the ratio of the Aid flow (current US$) in China in 2000 to that in 2001?
Give a very brief answer. 0.32. What is the ratio of the Aid flow (current US$) in Cote d'Ivoire in 2000 to that in 2001?
Ensure brevity in your answer.  5.13. What is the ratio of the Aid flow (current US$) in Georgia in 2000 to that in 2001?
Make the answer very short. 0.79. What is the ratio of the Aid flow (current US$) in Albania in 2000 to that in 2002?
Provide a succinct answer. 0.72. What is the ratio of the Aid flow (current US$) of China in 2000 to that in 2002?
Make the answer very short. 0.09. What is the ratio of the Aid flow (current US$) in Cote d'Ivoire in 2000 to that in 2002?
Your answer should be compact. 0.19. What is the ratio of the Aid flow (current US$) in Georgia in 2000 to that in 2002?
Make the answer very short. 0.56. What is the ratio of the Aid flow (current US$) in Albania in 2000 to that in 2003?
Your answer should be compact. 1.12. What is the ratio of the Aid flow (current US$) in China in 2000 to that in 2003?
Provide a succinct answer. 0.06. What is the ratio of the Aid flow (current US$) in Cote d'Ivoire in 2000 to that in 2003?
Provide a succinct answer. 0.16. What is the ratio of the Aid flow (current US$) of Albania in 2000 to that in 2004?
Your response must be concise. 1.11. What is the ratio of the Aid flow (current US$) in China in 2000 to that in 2004?
Make the answer very short. 0.07. What is the ratio of the Aid flow (current US$) in Cote d'Ivoire in 2000 to that in 2004?
Make the answer very short. 0.32. What is the ratio of the Aid flow (current US$) in Georgia in 2000 to that in 2004?
Keep it short and to the point. 0.81. What is the ratio of the Aid flow (current US$) in Albania in 2000 to that in 2005?
Offer a terse response. 1.24. What is the ratio of the Aid flow (current US$) in China in 2000 to that in 2005?
Provide a short and direct response. 0.07. What is the ratio of the Aid flow (current US$) of Cote d'Ivoire in 2000 to that in 2005?
Keep it short and to the point. 0.42. What is the ratio of the Aid flow (current US$) in Georgia in 2000 to that in 2005?
Offer a very short reply. 1.04. What is the ratio of the Aid flow (current US$) in Albania in 2000 to that in 2006?
Give a very brief answer. 1.1. What is the ratio of the Aid flow (current US$) of China in 2000 to that in 2006?
Keep it short and to the point. 0.08. What is the ratio of the Aid flow (current US$) of Cote d'Ivoire in 2000 to that in 2006?
Give a very brief answer. 0.32. What is the ratio of the Aid flow (current US$) of Georgia in 2000 to that in 2006?
Provide a succinct answer. 0.72. What is the ratio of the Aid flow (current US$) in Albania in 2001 to that in 2002?
Provide a short and direct response. 0.68. What is the ratio of the Aid flow (current US$) of China in 2001 to that in 2002?
Make the answer very short. 0.28. What is the ratio of the Aid flow (current US$) of Cote d'Ivoire in 2001 to that in 2002?
Keep it short and to the point. 0.04. What is the ratio of the Aid flow (current US$) in Georgia in 2001 to that in 2002?
Your answer should be very brief. 0.71. What is the ratio of the Aid flow (current US$) of Albania in 2001 to that in 2003?
Make the answer very short. 1.06. What is the ratio of the Aid flow (current US$) in China in 2001 to that in 2003?
Offer a terse response. 0.19. What is the ratio of the Aid flow (current US$) in Cote d'Ivoire in 2001 to that in 2003?
Provide a short and direct response. 0.03. What is the ratio of the Aid flow (current US$) of Georgia in 2001 to that in 2003?
Your response must be concise. 1.26. What is the ratio of the Aid flow (current US$) in Albania in 2001 to that in 2004?
Provide a succinct answer. 1.05. What is the ratio of the Aid flow (current US$) in China in 2001 to that in 2004?
Provide a short and direct response. 0.23. What is the ratio of the Aid flow (current US$) in Cote d'Ivoire in 2001 to that in 2004?
Offer a terse response. 0.06. What is the ratio of the Aid flow (current US$) in Georgia in 2001 to that in 2004?
Your answer should be compact. 1.02. What is the ratio of the Aid flow (current US$) in Albania in 2001 to that in 2005?
Provide a succinct answer. 1.17. What is the ratio of the Aid flow (current US$) in China in 2001 to that in 2005?
Make the answer very short. 0.21. What is the ratio of the Aid flow (current US$) in Cote d'Ivoire in 2001 to that in 2005?
Your answer should be very brief. 0.08. What is the ratio of the Aid flow (current US$) in Georgia in 2001 to that in 2005?
Give a very brief answer. 1.31. What is the ratio of the Aid flow (current US$) in Albania in 2001 to that in 2006?
Ensure brevity in your answer.  1.04. What is the ratio of the Aid flow (current US$) of China in 2001 to that in 2006?
Provide a short and direct response. 0.26. What is the ratio of the Aid flow (current US$) of Cote d'Ivoire in 2001 to that in 2006?
Your response must be concise. 0.06. What is the ratio of the Aid flow (current US$) of Georgia in 2001 to that in 2006?
Make the answer very short. 0.91. What is the ratio of the Aid flow (current US$) in Albania in 2002 to that in 2003?
Give a very brief answer. 1.55. What is the ratio of the Aid flow (current US$) of China in 2002 to that in 2003?
Give a very brief answer. 0.66. What is the ratio of the Aid flow (current US$) of Cote d'Ivoire in 2002 to that in 2003?
Provide a short and direct response. 0.85. What is the ratio of the Aid flow (current US$) of Georgia in 2002 to that in 2003?
Keep it short and to the point. 1.78. What is the ratio of the Aid flow (current US$) in Albania in 2002 to that in 2004?
Your answer should be very brief. 1.53. What is the ratio of the Aid flow (current US$) of China in 2002 to that in 2004?
Give a very brief answer. 0.79. What is the ratio of the Aid flow (current US$) of Cote d'Ivoire in 2002 to that in 2004?
Ensure brevity in your answer.  1.67. What is the ratio of the Aid flow (current US$) in Georgia in 2002 to that in 2004?
Ensure brevity in your answer.  1.44. What is the ratio of the Aid flow (current US$) in Albania in 2002 to that in 2005?
Offer a terse response. 1.72. What is the ratio of the Aid flow (current US$) of China in 2002 to that in 2005?
Give a very brief answer. 0.73. What is the ratio of the Aid flow (current US$) in Cote d'Ivoire in 2002 to that in 2005?
Your answer should be very brief. 2.23. What is the ratio of the Aid flow (current US$) of Georgia in 2002 to that in 2005?
Make the answer very short. 1.85. What is the ratio of the Aid flow (current US$) in Albania in 2002 to that in 2006?
Provide a short and direct response. 1.52. What is the ratio of the Aid flow (current US$) in China in 2002 to that in 2006?
Keep it short and to the point. 0.9. What is the ratio of the Aid flow (current US$) in Cote d'Ivoire in 2002 to that in 2006?
Ensure brevity in your answer.  1.72. What is the ratio of the Aid flow (current US$) in Georgia in 2002 to that in 2006?
Your answer should be very brief. 1.29. What is the ratio of the Aid flow (current US$) in China in 2003 to that in 2004?
Your response must be concise. 1.19. What is the ratio of the Aid flow (current US$) of Cote d'Ivoire in 2003 to that in 2004?
Keep it short and to the point. 1.97. What is the ratio of the Aid flow (current US$) in Georgia in 2003 to that in 2004?
Offer a terse response. 0.81. What is the ratio of the Aid flow (current US$) in Albania in 2003 to that in 2005?
Ensure brevity in your answer.  1.11. What is the ratio of the Aid flow (current US$) in China in 2003 to that in 2005?
Make the answer very short. 1.11. What is the ratio of the Aid flow (current US$) of Cote d'Ivoire in 2003 to that in 2005?
Give a very brief answer. 2.63. What is the ratio of the Aid flow (current US$) of Georgia in 2003 to that in 2005?
Provide a short and direct response. 1.04. What is the ratio of the Aid flow (current US$) of Albania in 2003 to that in 2006?
Your answer should be compact. 0.99. What is the ratio of the Aid flow (current US$) of China in 2003 to that in 2006?
Your answer should be very brief. 1.36. What is the ratio of the Aid flow (current US$) of Cote d'Ivoire in 2003 to that in 2006?
Offer a very short reply. 2.02. What is the ratio of the Aid flow (current US$) in Georgia in 2003 to that in 2006?
Offer a terse response. 0.73. What is the ratio of the Aid flow (current US$) of Albania in 2004 to that in 2005?
Your answer should be very brief. 1.12. What is the ratio of the Aid flow (current US$) in China in 2004 to that in 2005?
Give a very brief answer. 0.93. What is the ratio of the Aid flow (current US$) of Cote d'Ivoire in 2004 to that in 2005?
Ensure brevity in your answer.  1.34. What is the ratio of the Aid flow (current US$) in Georgia in 2004 to that in 2005?
Provide a succinct answer. 1.28. What is the ratio of the Aid flow (current US$) of China in 2004 to that in 2006?
Provide a short and direct response. 1.14. What is the ratio of the Aid flow (current US$) of Cote d'Ivoire in 2004 to that in 2006?
Keep it short and to the point. 1.03. What is the ratio of the Aid flow (current US$) of Georgia in 2004 to that in 2006?
Provide a short and direct response. 0.89. What is the ratio of the Aid flow (current US$) of Albania in 2005 to that in 2006?
Ensure brevity in your answer.  0.89. What is the ratio of the Aid flow (current US$) of China in 2005 to that in 2006?
Offer a terse response. 1.23. What is the ratio of the Aid flow (current US$) in Cote d'Ivoire in 2005 to that in 2006?
Provide a short and direct response. 0.77. What is the ratio of the Aid flow (current US$) of Georgia in 2005 to that in 2006?
Give a very brief answer. 0.7. What is the difference between the highest and the second highest Aid flow (current US$) of Albania?
Your answer should be compact. 1.71e+07. What is the difference between the highest and the second highest Aid flow (current US$) of China?
Keep it short and to the point. 2.46e+06. What is the difference between the highest and the second highest Aid flow (current US$) in Cote d'Ivoire?
Offer a very short reply. 9.53e+06. What is the difference between the highest and the second highest Aid flow (current US$) in Georgia?
Your answer should be compact. 3.01e+07. What is the difference between the highest and the lowest Aid flow (current US$) of Albania?
Your answer should be compact. 2.58e+07. What is the difference between the highest and the lowest Aid flow (current US$) in China?
Provide a short and direct response. 2.41e+07. What is the difference between the highest and the lowest Aid flow (current US$) in Cote d'Ivoire?
Give a very brief answer. 6.06e+07. What is the difference between the highest and the lowest Aid flow (current US$) of Georgia?
Keep it short and to the point. 6.13e+07. 